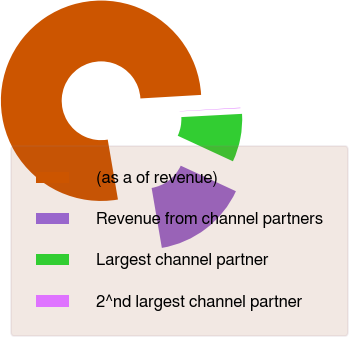Convert chart. <chart><loc_0><loc_0><loc_500><loc_500><pie_chart><fcel>(as a of revenue)<fcel>Revenue from channel partners<fcel>Largest channel partner<fcel>2^nd largest channel partner<nl><fcel>76.76%<fcel>15.41%<fcel>7.75%<fcel>0.08%<nl></chart> 